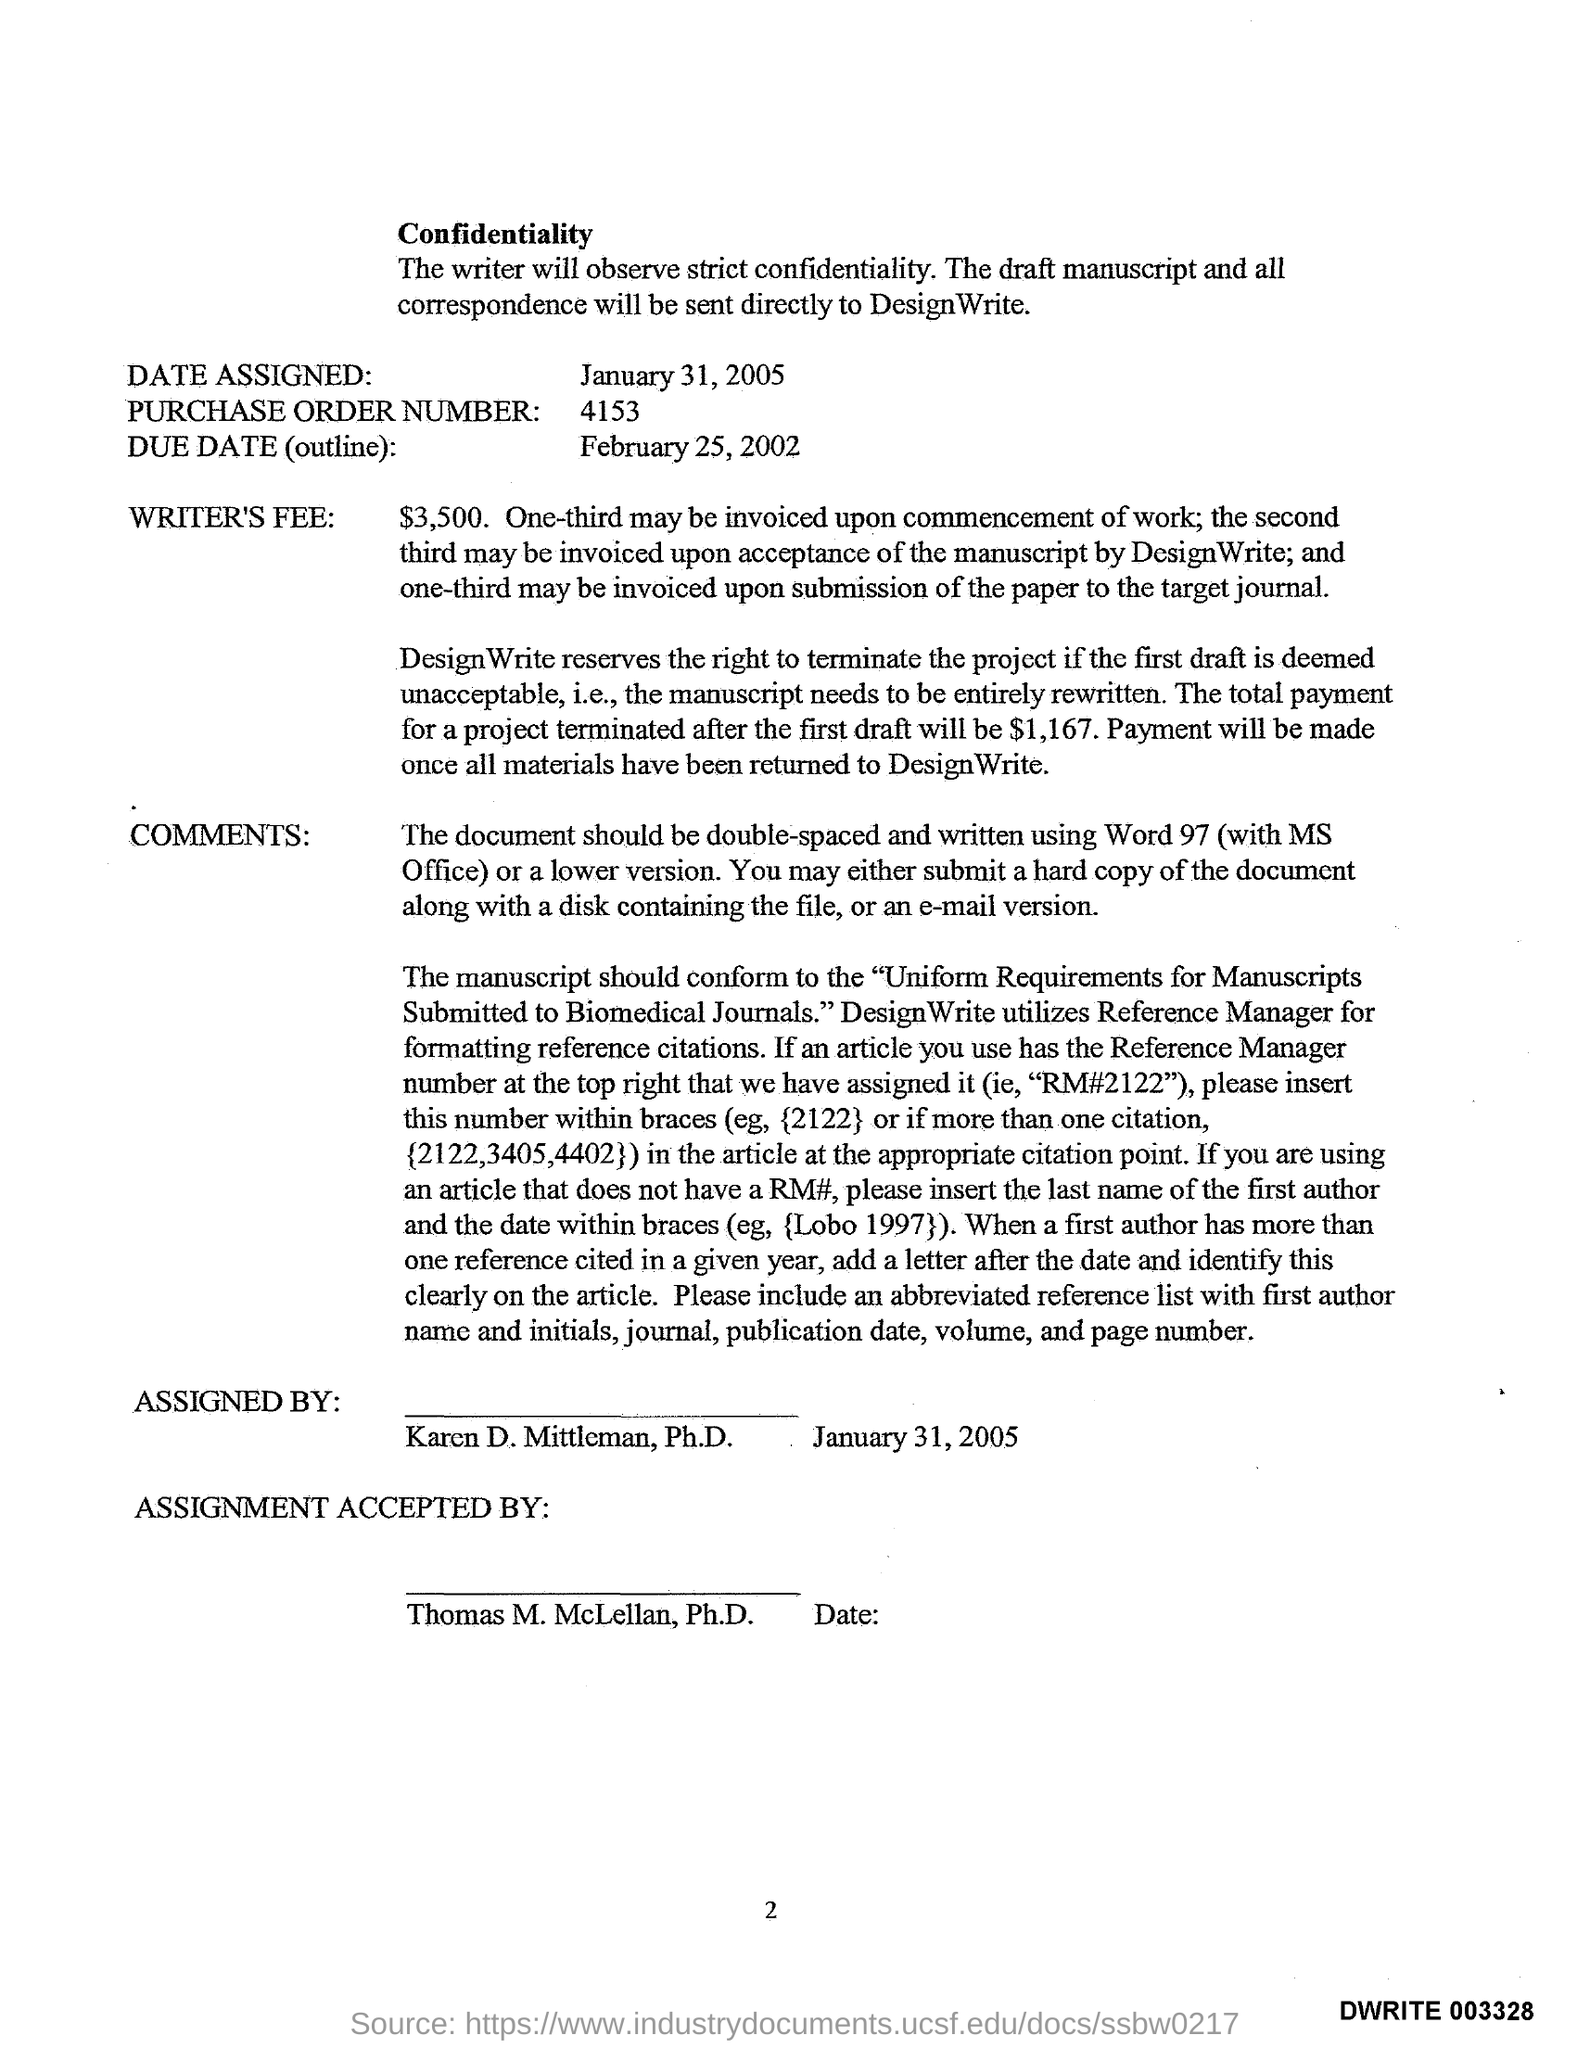What is the purchase order number?
Offer a terse response. 4153. What is the due date(outline)?
Your response must be concise. February 25, 2002. 